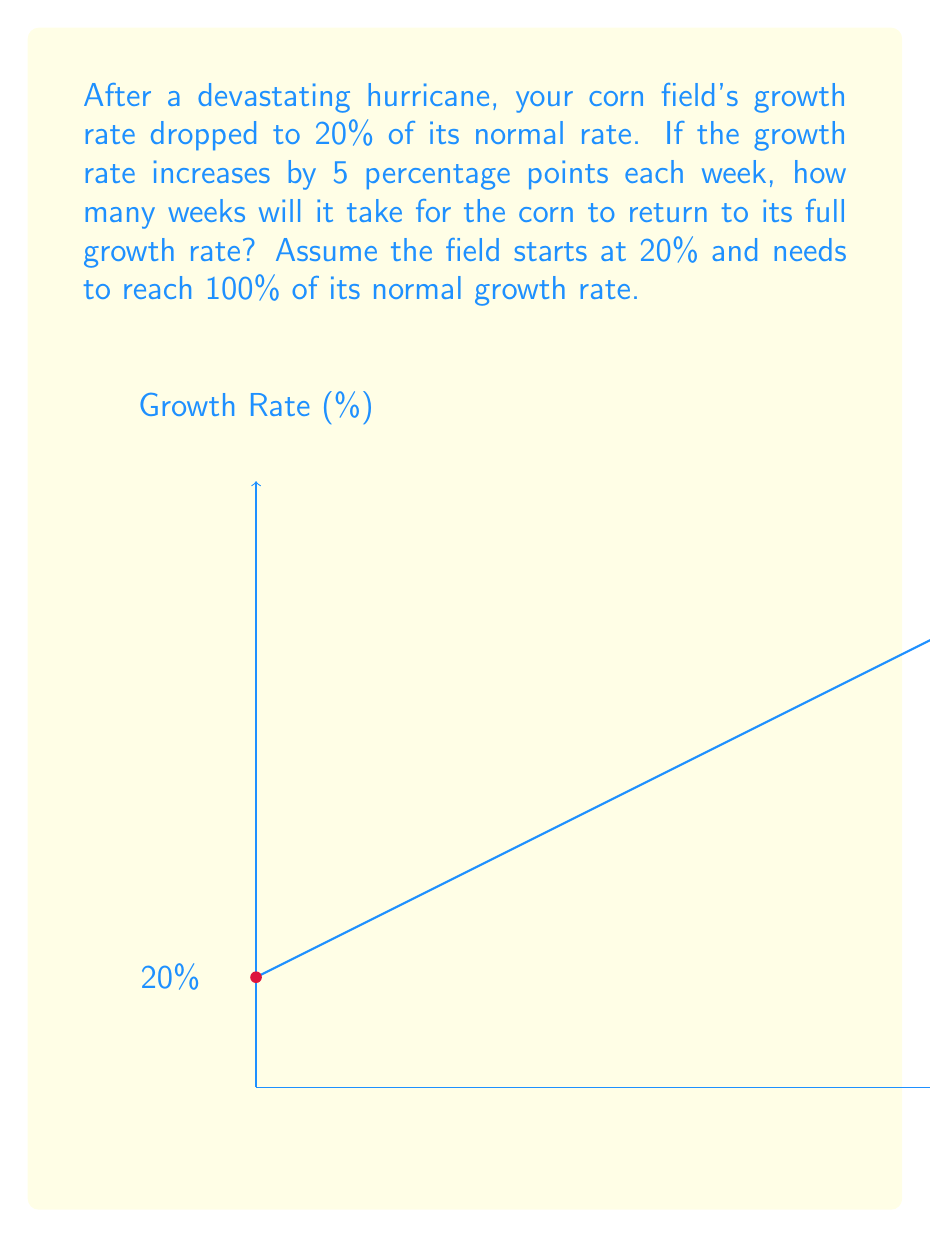Help me with this question. Let's approach this step-by-step:

1) We start with the initial growth rate at 20% of normal.

2) Each week, the growth rate increases by 5 percentage points.

3) We need to find how many weeks it takes to reach 100%.

4) We can set up an equation:
   $$ 20 + 5x = 100 $$
   Where $x$ is the number of weeks.

5) Solving for $x$:
   $$ 5x = 100 - 20 $$
   $$ 5x = 80 $$
   $$ x = 80 \div 5 = 16 $$

6) We can verify:
   Initial: 20%
   After 16 weeks: $20 + (16 \times 5) = 20 + 80 = 100\%$

Therefore, it will take 16 weeks for the corn to return to its full growth rate.
Answer: 16 weeks 